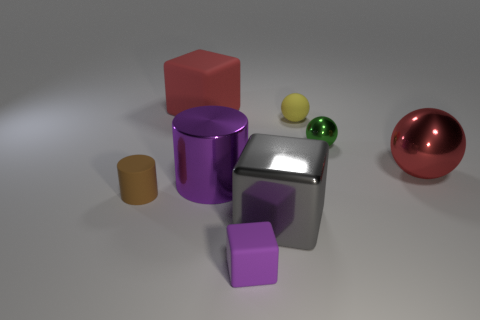The matte thing that is left of the large cylinder and behind the red shiny sphere has what shape?
Give a very brief answer. Cube. What number of big shiny things have the same color as the big matte cube?
Provide a succinct answer. 1. There is a block that is to the left of the big gray metallic block and in front of the green metallic ball; what is its size?
Keep it short and to the point. Small. What number of tiny spheres have the same material as the brown thing?
Your answer should be very brief. 1. There is a tiny thing that is in front of the tiny yellow thing and to the right of the small purple cube; what is its color?
Your response must be concise. Green. Is there any other thing that is the same shape as the purple rubber thing?
Your answer should be compact. Yes. There is another big metal thing that is the same shape as the green metal object; what color is it?
Keep it short and to the point. Red. Is the purple metallic thing the same size as the red ball?
Offer a terse response. Yes. There is a red shiny thing that is the same size as the gray metal block; what is its shape?
Your response must be concise. Sphere. There is a red cube that is the same material as the yellow ball; what is its size?
Offer a terse response. Large. 